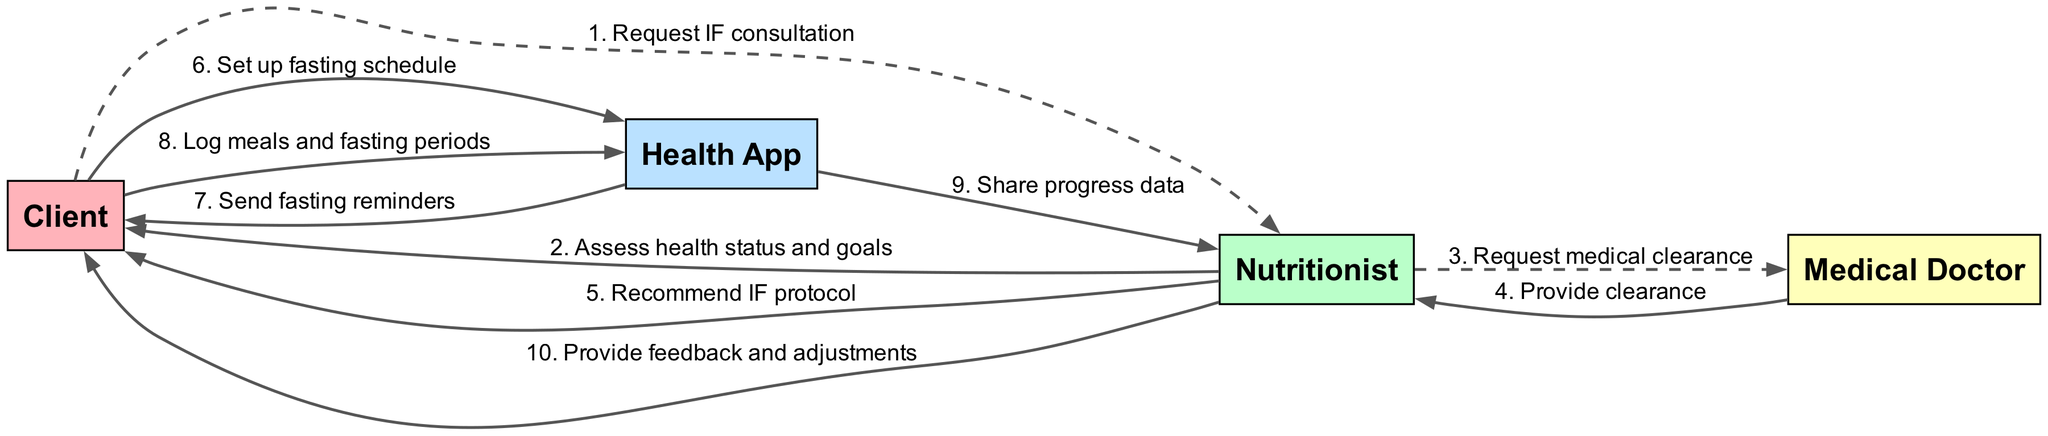What is the first action taken by the Client? The first action in the diagram shows the Client sending a request for intermittent fasting consultation to the Nutritionist. This establishes the initiation of the implementation process.
Answer: Request IF consultation How many actors are involved in the diagram? The diagram lists four distinct actors: Client, Nutritionist, Health App, and Medical Doctor. This count reflects the participants necessary for the protocol implementation.
Answer: 4 Who provides the medical clearance? According to the sequence in the diagram, the Medical Doctor is responsible for providing medical clearance to the Nutritionist after a request is made. This step is essential prior to recommending a protocol.
Answer: Medical Doctor What message does the Health App send to the Client? The Health App sends a message to the Client that includes reminders for fasting periods. This helps in monitoring the intermittent fasting schedule effectively.
Answer: Send fasting reminders Which actor shares progress data with the Nutritionist? The sequence indicates that the Health App shares progress data with the Nutritionist. This sharing of data allows the Nutritionist to assess how well the Client is adhering to the protocol.
Answer: Health App What is the last action taken by the Nutritionist in response to the Client? The Nutritionist provides feedback and adjustments to the Client, wrapping up the monitoring and advising phase of the diagram's sequence. This step demonstrates the ongoing support provided to the Client.
Answer: Provide feedback and adjustments Which actor is contacted after the Nutritionist assesses the Client's health status and goals? Following the initial assessment of the Client’s health status and goals, the Nutritionist contacts the Medical Doctor to request medical clearance. This indicates the collaboration between health professionals.
Answer: Medical Doctor How many messages are exchanged in the diagram? The diagram depicts a total of ten messages exchanged among the actors. This reflects the sequence of actions and communications necessary for implementing the intermittent fasting protocol.
Answer: 10 What action does the Client take after receiving the IF protocol recommendation? After receiving the recommendation for the intermittent fasting protocol, the Client sets up a fasting schedule in the Health App. This step is critical for the Client to adhere to the proposed protocol.
Answer: Set up fasting schedule 